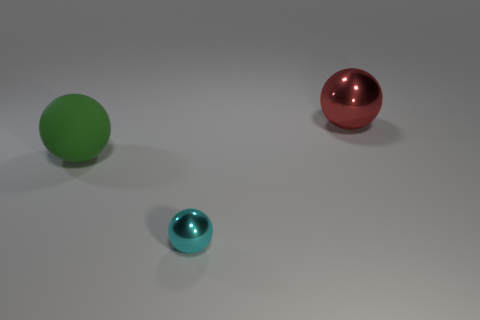Add 2 cyan matte balls. How many objects exist? 5 Add 3 big purple metal cylinders. How many big purple metal cylinders exist? 3 Subtract 0 purple balls. How many objects are left? 3 Subtract all small blue objects. Subtract all cyan metal spheres. How many objects are left? 2 Add 2 small metal spheres. How many small metal spheres are left? 3 